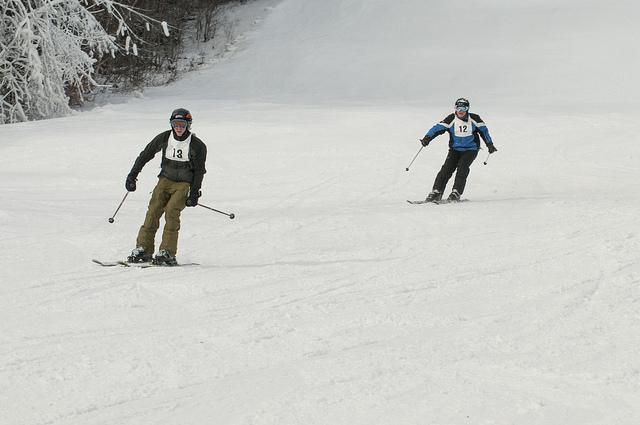How many athletes are there?
Give a very brief answer. 2. How many people are there?
Give a very brief answer. 2. How many people are wearing goggles?
Give a very brief answer. 2. How many people can be seen?
Give a very brief answer. 2. 